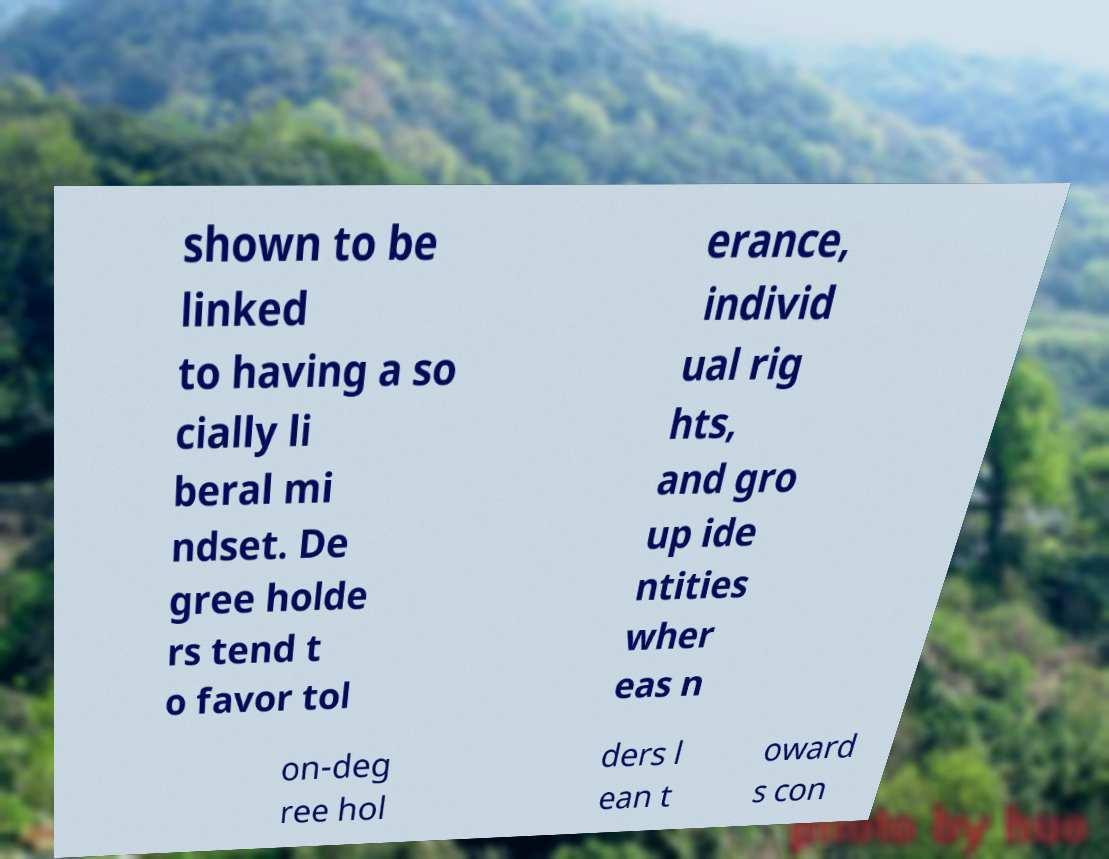Could you extract and type out the text from this image? shown to be linked to having a so cially li beral mi ndset. De gree holde rs tend t o favor tol erance, individ ual rig hts, and gro up ide ntities wher eas n on-deg ree hol ders l ean t oward s con 